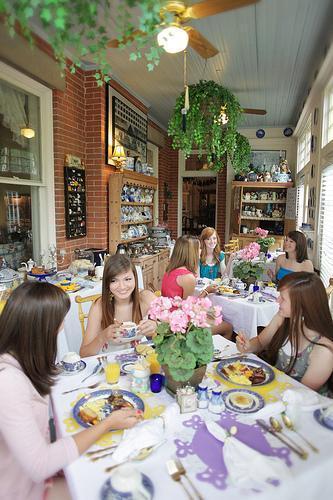How many people are there?
Give a very brief answer. 6. How many table does not have anyone sitting there?
Give a very brief answer. 1. 